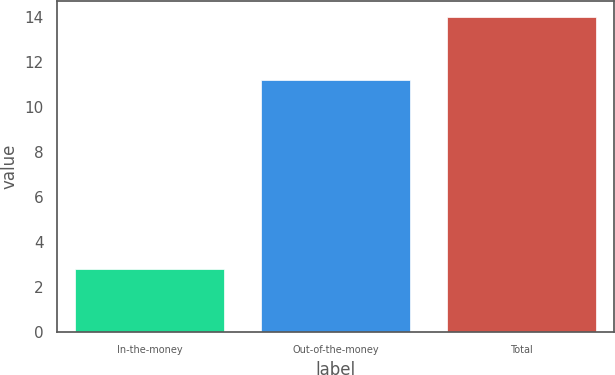Convert chart to OTSL. <chart><loc_0><loc_0><loc_500><loc_500><bar_chart><fcel>In-the-money<fcel>Out-of-the-money<fcel>Total<nl><fcel>2.8<fcel>11.2<fcel>14<nl></chart> 